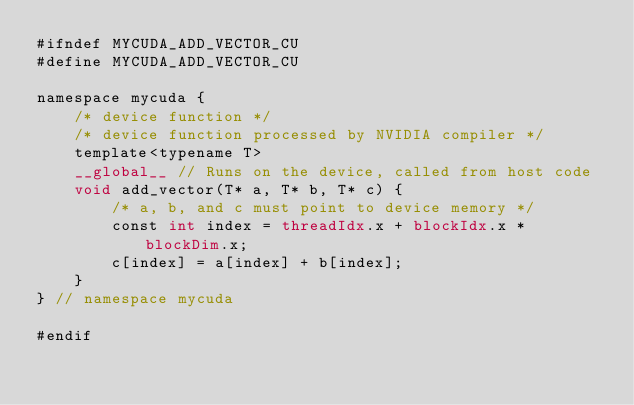Convert code to text. <code><loc_0><loc_0><loc_500><loc_500><_Cuda_>#ifndef MYCUDA_ADD_VECTOR_CU
#define MYCUDA_ADD_VECTOR_CU

namespace mycuda {
    /* device function */
    /* device function processed by NVIDIA compiler */
    template<typename T>
    __global__ // Runs on the device, called from host code
    void add_vector(T* a, T* b, T* c) {
        /* a, b, and c must point to device memory */
        const int index = threadIdx.x + blockIdx.x * blockDim.x;
        c[index] = a[index] + b[index];
    }
} // namespace mycuda

#endif
</code> 